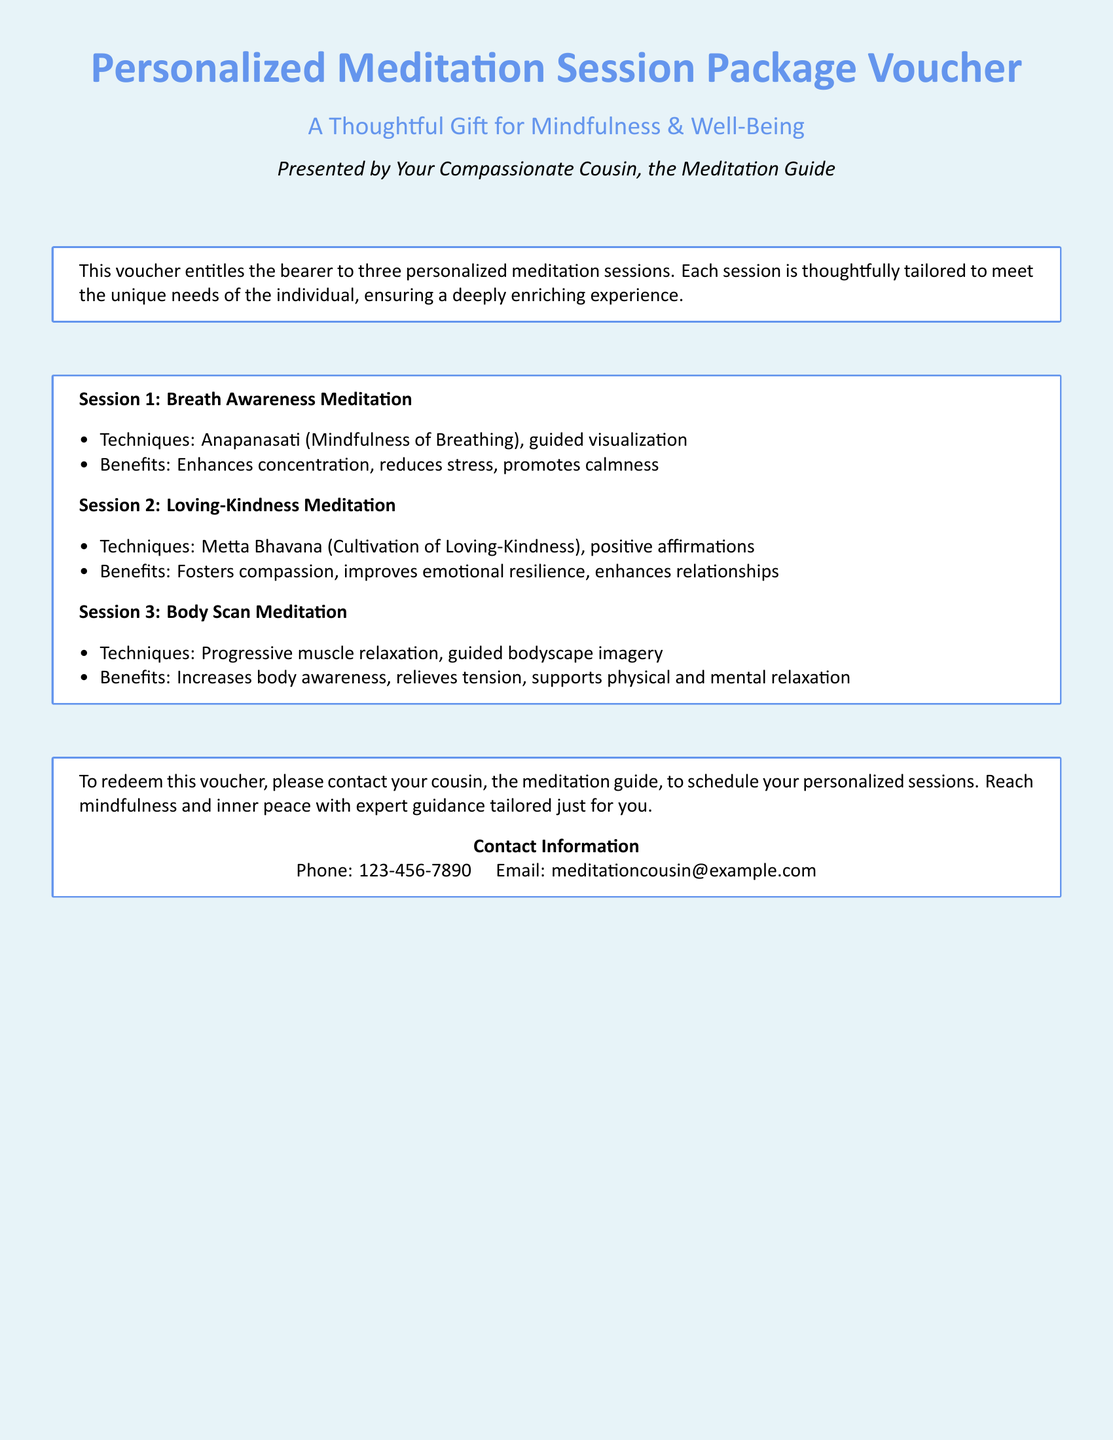what does the voucher offer? The voucher offers three personalized meditation sessions tailored specifically to the recipient's needs.
Answer: three personalized meditation sessions who presented the voucher? The voucher is presented by Your Compassionate Cousin, the Meditation Guide.
Answer: Your Compassionate Cousin, the Meditation Guide what is the first session called? The first session is called Breath Awareness Meditation.
Answer: Breath Awareness Meditation how many benefits are listed for each session? Each session includes a list of two benefits as described in the document.
Answer: two benefits what technique is used in the second session? The technique used in the second session is Metta Bhavana (Cultivation of Loving-Kindness).
Answer: Metta Bhavana (Cultivation of Loving-Kindness) how can the bearer redeem the voucher? The bearer can redeem the voucher by contacting their cousin to schedule personalized sessions.
Answer: by contacting their cousin what is the phone number provided in the document? The document provides a phone number that can be used for contact, which is stated clearly.
Answer: 123-456-7890 what is the benefit of the Body Scan Meditation session? The listed benefits for the Body Scan Meditation include increasing body awareness, relieving tension, and supporting relaxation.
Answer: Increases body awareness, relieves tension, supports relaxation what is the color theme of the voucher? The color theme of the voucher is light blue and med blue as described in the document.
Answer: light blue and med blue 